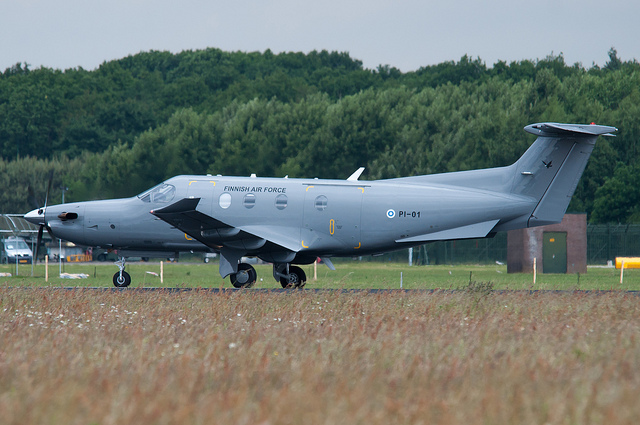<image>What country is this? I am not sure what country this is. It could be France or Finland. What country is this? I am not sure what country this is. It can be either France, Finland, or the USA. 